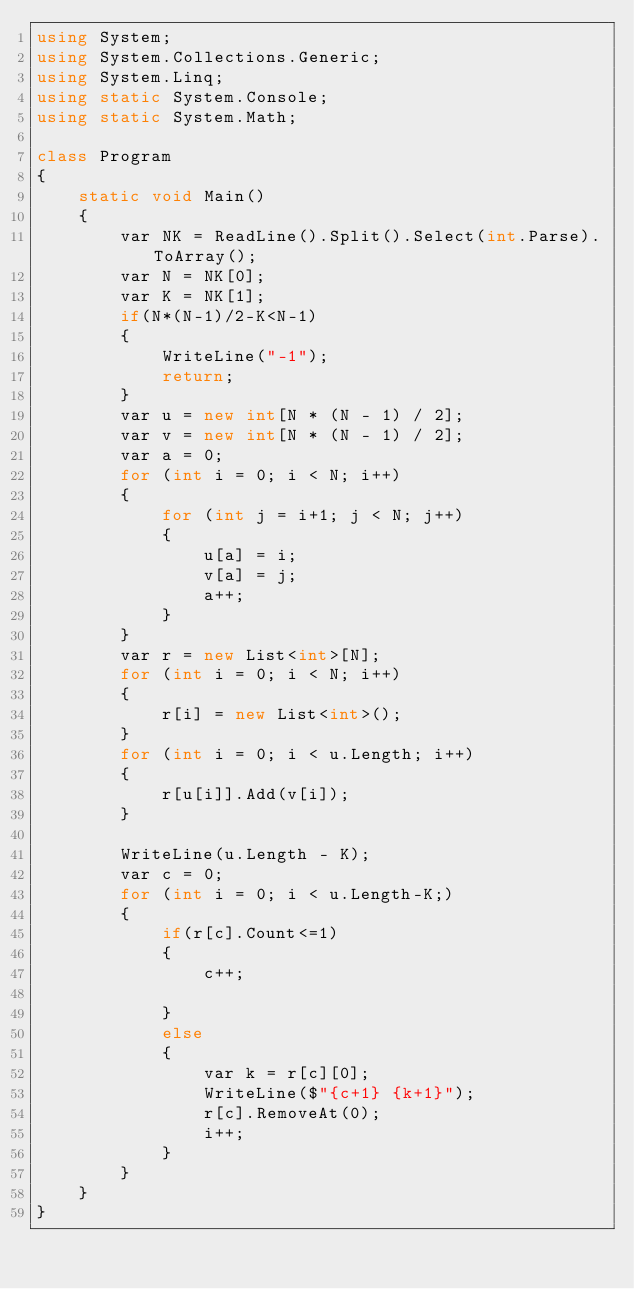Convert code to text. <code><loc_0><loc_0><loc_500><loc_500><_C#_>using System;
using System.Collections.Generic;
using System.Linq;
using static System.Console;
using static System.Math;

class Program
{
    static void Main()
    {
        var NK = ReadLine().Split().Select(int.Parse).ToArray();
        var N = NK[0];
        var K = NK[1];
        if(N*(N-1)/2-K<N-1)
        {
            WriteLine("-1");
            return;
        }
        var u = new int[N * (N - 1) / 2];
        var v = new int[N * (N - 1) / 2];
        var a = 0;
        for (int i = 0; i < N; i++)
        {
            for (int j = i+1; j < N; j++)
            {
                u[a] = i;
                v[a] = j;
                a++;
            }
        }
        var r = new List<int>[N];
        for (int i = 0; i < N; i++)
        {
            r[i] = new List<int>();
        }
        for (int i = 0; i < u.Length; i++)
        {
            r[u[i]].Add(v[i]);
        }

        WriteLine(u.Length - K);
        var c = 0;
        for (int i = 0; i < u.Length-K;)
        {
            if(r[c].Count<=1)
            {
                c++;
                
            }
            else
            {
                var k = r[c][0];
                WriteLine($"{c+1} {k+1}");
                r[c].RemoveAt(0);
                i++;
            }
        }
    }
}</code> 